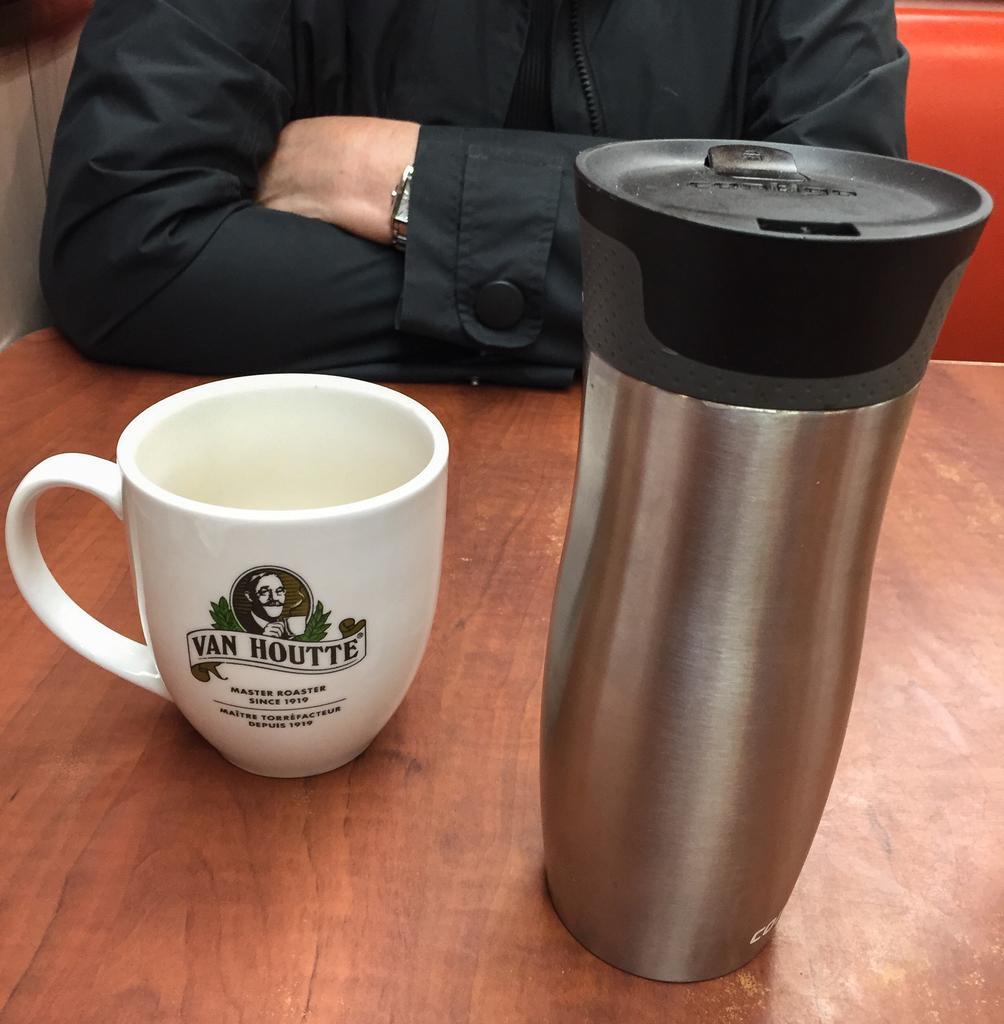Describe this image in one or two sentences. There is a person sitting,in front of this person we can see cup and bottle on the table,beside this person we can see wall. 